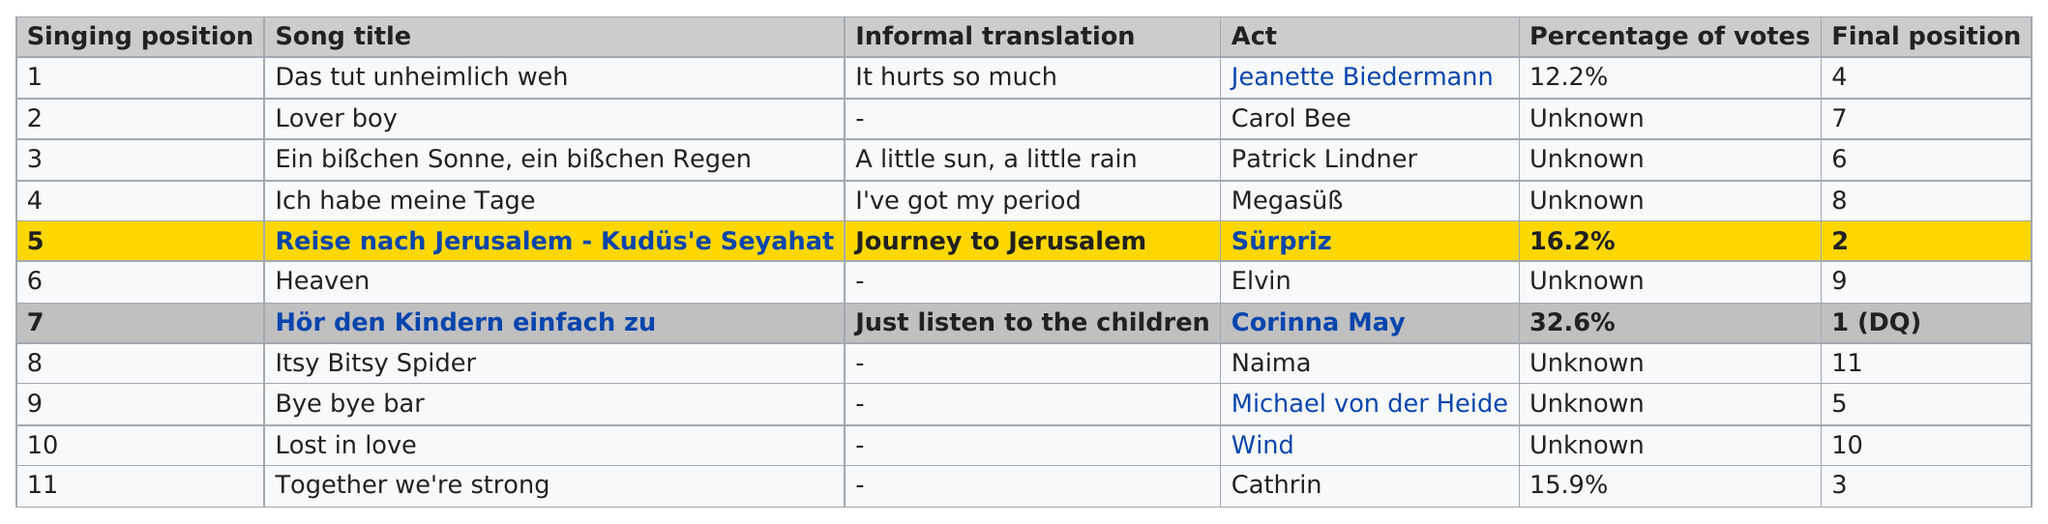List a handful of essential elements in this visual. Out of the total number of votes cast, 4% were for "Reise nach Jerusalem - Kudüs'e Seyahat," while only "Das Tut Unheimlich Weh" received 4% of the votes. Journey to Jerusalem had a greater percentage of votes than the other option, which caused great pain. What song took the last place? It is 'Itsy Bitsy Spider'. The top song title is 'Das Tut Unheimlich Weh.' The song that won the competition was 'Hör den Kindern einfach zu..'. 